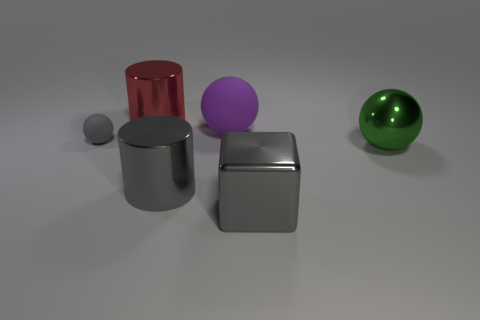Can you describe the colors of the objects in the image? Certainly! From left to right, there's a small gray metallic sphere, a large red cylinder, a purple sphere, a silver cube, and a green sphere. Each object has a smooth, reflective surface that slightly mirrors its surroundings. 